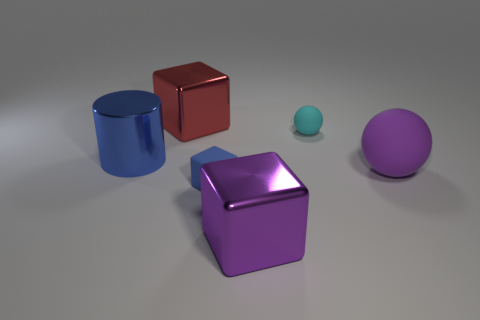Add 3 purple blocks. How many objects exist? 9 Subtract all cylinders. How many objects are left? 5 Subtract 0 blue spheres. How many objects are left? 6 Subtract all big purple things. Subtract all cyan matte spheres. How many objects are left? 3 Add 2 large blocks. How many large blocks are left? 4 Add 3 large metallic cubes. How many large metallic cubes exist? 5 